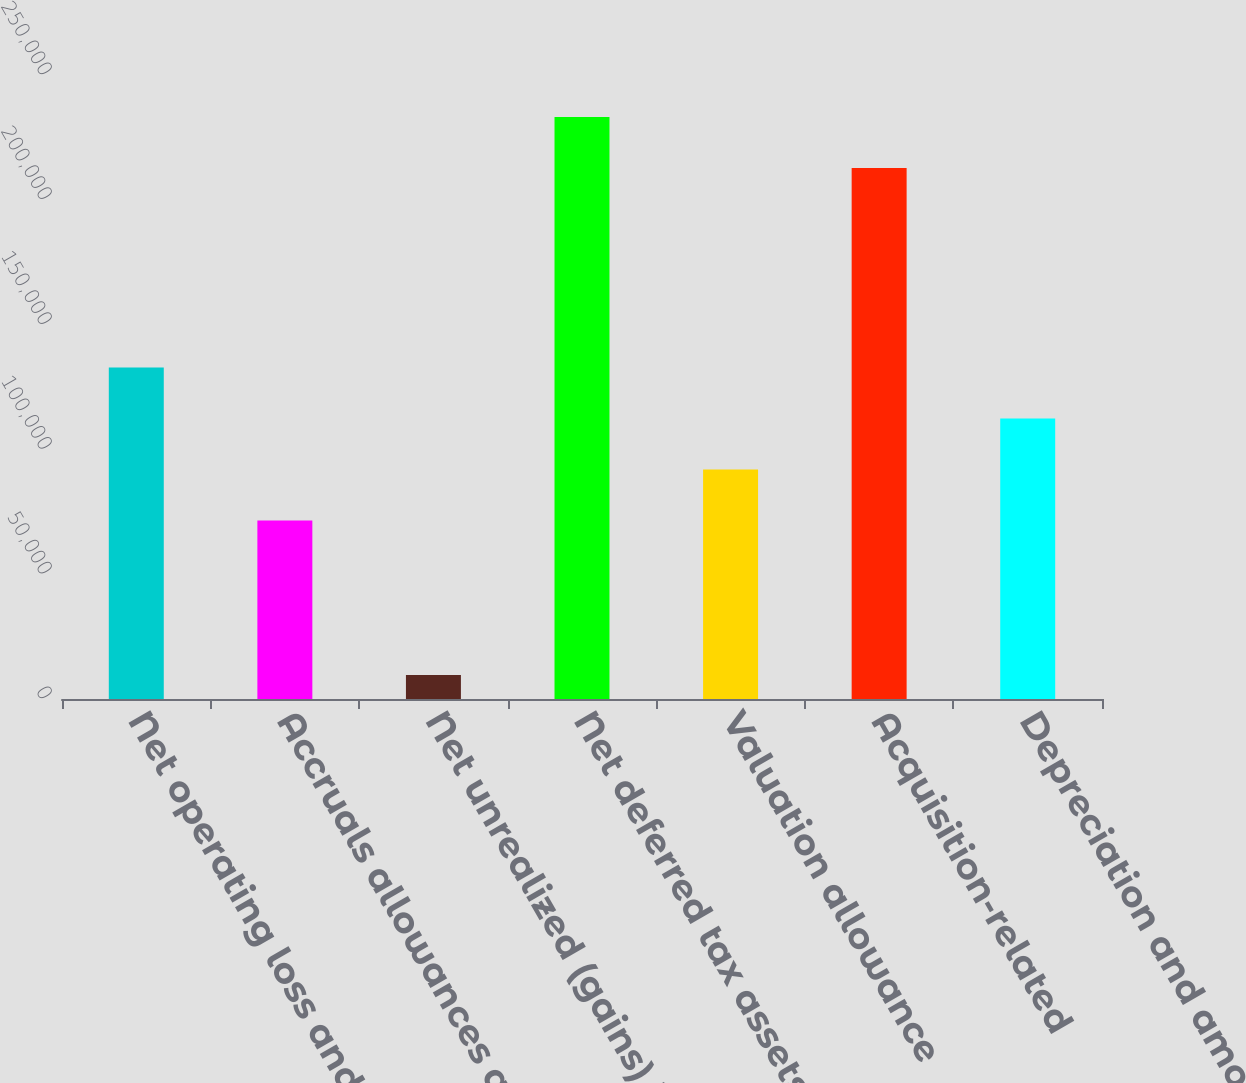<chart> <loc_0><loc_0><loc_500><loc_500><bar_chart><fcel>Net operating loss and credits<fcel>Accruals allowances and<fcel>Net unrealized (gains) losses<fcel>Net deferred tax assets<fcel>Valuation allowance<fcel>Acquisition-related<fcel>Depreciation and amortization<nl><fcel>132832<fcel>71504<fcel>9616<fcel>233136<fcel>91937.6<fcel>212702<fcel>112371<nl></chart> 